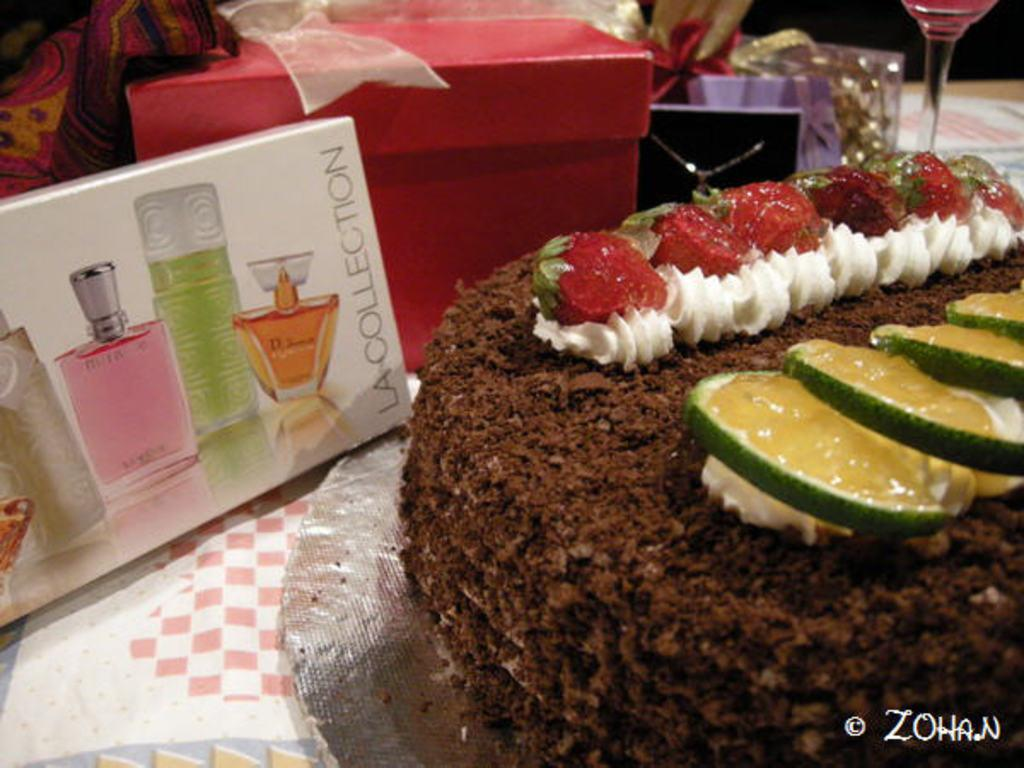<image>
Share a concise interpretation of the image provided. a cake next to an LA Collection perfume gift box 